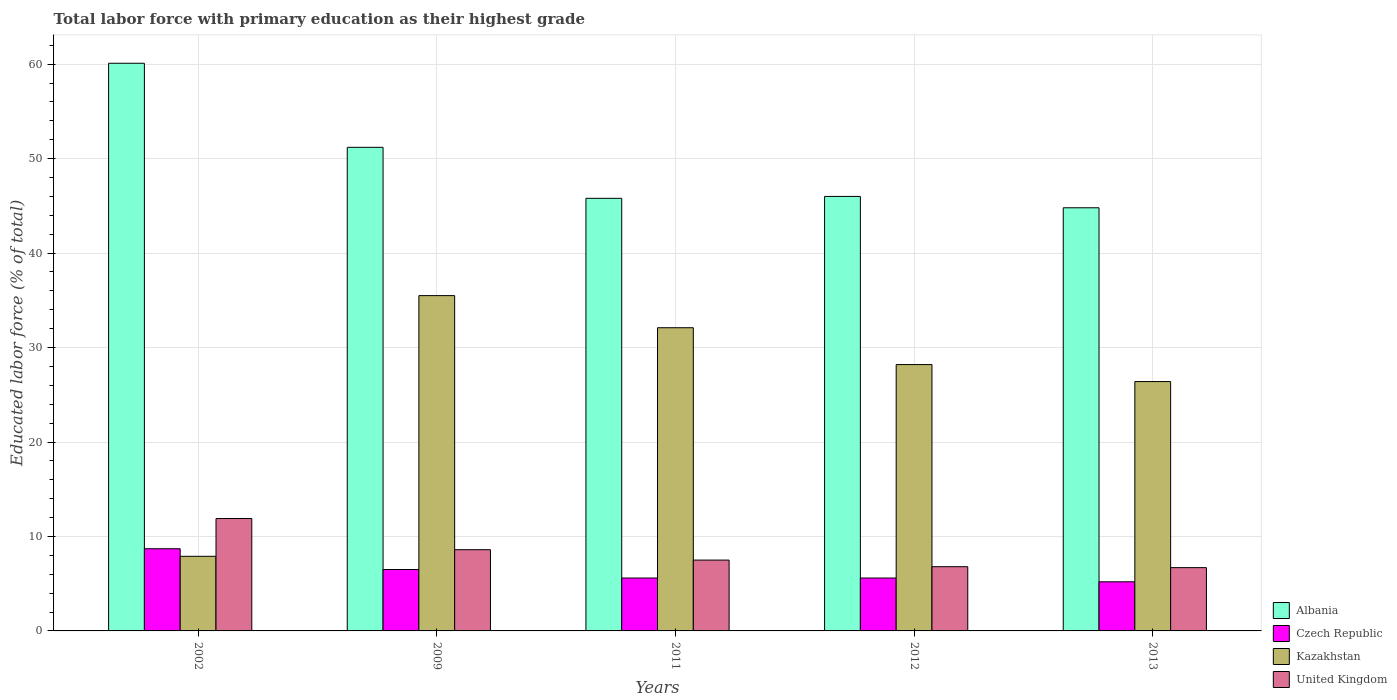How many groups of bars are there?
Keep it short and to the point. 5. Are the number of bars per tick equal to the number of legend labels?
Your answer should be very brief. Yes. Are the number of bars on each tick of the X-axis equal?
Give a very brief answer. Yes. How many bars are there on the 1st tick from the right?
Provide a short and direct response. 4. What is the label of the 1st group of bars from the left?
Your answer should be very brief. 2002. What is the percentage of total labor force with primary education in Czech Republic in 2013?
Provide a succinct answer. 5.2. Across all years, what is the maximum percentage of total labor force with primary education in United Kingdom?
Give a very brief answer. 11.9. Across all years, what is the minimum percentage of total labor force with primary education in Kazakhstan?
Your response must be concise. 7.9. In which year was the percentage of total labor force with primary education in Albania maximum?
Give a very brief answer. 2002. What is the total percentage of total labor force with primary education in Kazakhstan in the graph?
Provide a short and direct response. 130.1. What is the difference between the percentage of total labor force with primary education in Kazakhstan in 2009 and that in 2013?
Provide a short and direct response. 9.1. What is the difference between the percentage of total labor force with primary education in Czech Republic in 2002 and the percentage of total labor force with primary education in United Kingdom in 2013?
Your answer should be very brief. 2. What is the average percentage of total labor force with primary education in Kazakhstan per year?
Offer a terse response. 26.02. In the year 2009, what is the difference between the percentage of total labor force with primary education in United Kingdom and percentage of total labor force with primary education in Albania?
Your response must be concise. -42.6. In how many years, is the percentage of total labor force with primary education in Czech Republic greater than 20 %?
Ensure brevity in your answer.  0. What is the ratio of the percentage of total labor force with primary education in Albania in 2002 to that in 2013?
Give a very brief answer. 1.34. Is the percentage of total labor force with primary education in Kazakhstan in 2009 less than that in 2012?
Keep it short and to the point. No. What is the difference between the highest and the second highest percentage of total labor force with primary education in Czech Republic?
Your answer should be compact. 2.2. What is the difference between the highest and the lowest percentage of total labor force with primary education in Czech Republic?
Offer a terse response. 3.5. In how many years, is the percentage of total labor force with primary education in Czech Republic greater than the average percentage of total labor force with primary education in Czech Republic taken over all years?
Give a very brief answer. 2. Is it the case that in every year, the sum of the percentage of total labor force with primary education in Kazakhstan and percentage of total labor force with primary education in Czech Republic is greater than the sum of percentage of total labor force with primary education in United Kingdom and percentage of total labor force with primary education in Albania?
Give a very brief answer. No. What does the 4th bar from the left in 2013 represents?
Ensure brevity in your answer.  United Kingdom. What does the 4th bar from the right in 2002 represents?
Provide a succinct answer. Albania. How many years are there in the graph?
Ensure brevity in your answer.  5. Does the graph contain grids?
Ensure brevity in your answer.  Yes. How many legend labels are there?
Offer a terse response. 4. How are the legend labels stacked?
Your answer should be very brief. Vertical. What is the title of the graph?
Offer a very short reply. Total labor force with primary education as their highest grade. Does "Lao PDR" appear as one of the legend labels in the graph?
Give a very brief answer. No. What is the label or title of the X-axis?
Ensure brevity in your answer.  Years. What is the label or title of the Y-axis?
Make the answer very short. Educated labor force (% of total). What is the Educated labor force (% of total) in Albania in 2002?
Offer a very short reply. 60.1. What is the Educated labor force (% of total) of Czech Republic in 2002?
Provide a short and direct response. 8.7. What is the Educated labor force (% of total) of Kazakhstan in 2002?
Offer a terse response. 7.9. What is the Educated labor force (% of total) of United Kingdom in 2002?
Offer a terse response. 11.9. What is the Educated labor force (% of total) of Albania in 2009?
Provide a short and direct response. 51.2. What is the Educated labor force (% of total) in Czech Republic in 2009?
Give a very brief answer. 6.5. What is the Educated labor force (% of total) of Kazakhstan in 2009?
Give a very brief answer. 35.5. What is the Educated labor force (% of total) in United Kingdom in 2009?
Offer a very short reply. 8.6. What is the Educated labor force (% of total) of Albania in 2011?
Offer a terse response. 45.8. What is the Educated labor force (% of total) of Czech Republic in 2011?
Offer a very short reply. 5.6. What is the Educated labor force (% of total) in Kazakhstan in 2011?
Make the answer very short. 32.1. What is the Educated labor force (% of total) of Albania in 2012?
Offer a very short reply. 46. What is the Educated labor force (% of total) of Czech Republic in 2012?
Give a very brief answer. 5.6. What is the Educated labor force (% of total) in Kazakhstan in 2012?
Your response must be concise. 28.2. What is the Educated labor force (% of total) in United Kingdom in 2012?
Ensure brevity in your answer.  6.8. What is the Educated labor force (% of total) in Albania in 2013?
Provide a succinct answer. 44.8. What is the Educated labor force (% of total) in Czech Republic in 2013?
Your answer should be compact. 5.2. What is the Educated labor force (% of total) of Kazakhstan in 2013?
Ensure brevity in your answer.  26.4. What is the Educated labor force (% of total) of United Kingdom in 2013?
Your response must be concise. 6.7. Across all years, what is the maximum Educated labor force (% of total) of Albania?
Your answer should be very brief. 60.1. Across all years, what is the maximum Educated labor force (% of total) in Czech Republic?
Provide a succinct answer. 8.7. Across all years, what is the maximum Educated labor force (% of total) in Kazakhstan?
Your response must be concise. 35.5. Across all years, what is the maximum Educated labor force (% of total) in United Kingdom?
Make the answer very short. 11.9. Across all years, what is the minimum Educated labor force (% of total) of Albania?
Your answer should be compact. 44.8. Across all years, what is the minimum Educated labor force (% of total) of Czech Republic?
Your answer should be compact. 5.2. Across all years, what is the minimum Educated labor force (% of total) of Kazakhstan?
Keep it short and to the point. 7.9. Across all years, what is the minimum Educated labor force (% of total) in United Kingdom?
Your answer should be compact. 6.7. What is the total Educated labor force (% of total) in Albania in the graph?
Provide a short and direct response. 247.9. What is the total Educated labor force (% of total) of Czech Republic in the graph?
Offer a very short reply. 31.6. What is the total Educated labor force (% of total) of Kazakhstan in the graph?
Ensure brevity in your answer.  130.1. What is the total Educated labor force (% of total) of United Kingdom in the graph?
Provide a succinct answer. 41.5. What is the difference between the Educated labor force (% of total) in Kazakhstan in 2002 and that in 2009?
Give a very brief answer. -27.6. What is the difference between the Educated labor force (% of total) in United Kingdom in 2002 and that in 2009?
Provide a short and direct response. 3.3. What is the difference between the Educated labor force (% of total) of Albania in 2002 and that in 2011?
Ensure brevity in your answer.  14.3. What is the difference between the Educated labor force (% of total) in Czech Republic in 2002 and that in 2011?
Make the answer very short. 3.1. What is the difference between the Educated labor force (% of total) of Kazakhstan in 2002 and that in 2011?
Ensure brevity in your answer.  -24.2. What is the difference between the Educated labor force (% of total) in Kazakhstan in 2002 and that in 2012?
Offer a very short reply. -20.3. What is the difference between the Educated labor force (% of total) in Albania in 2002 and that in 2013?
Offer a terse response. 15.3. What is the difference between the Educated labor force (% of total) of Kazakhstan in 2002 and that in 2013?
Give a very brief answer. -18.5. What is the difference between the Educated labor force (% of total) of Albania in 2009 and that in 2011?
Your answer should be compact. 5.4. What is the difference between the Educated labor force (% of total) of Czech Republic in 2009 and that in 2011?
Your answer should be very brief. 0.9. What is the difference between the Educated labor force (% of total) in United Kingdom in 2009 and that in 2013?
Give a very brief answer. 1.9. What is the difference between the Educated labor force (% of total) in Albania in 2011 and that in 2012?
Keep it short and to the point. -0.2. What is the difference between the Educated labor force (% of total) in Kazakhstan in 2011 and that in 2012?
Your answer should be very brief. 3.9. What is the difference between the Educated labor force (% of total) of United Kingdom in 2011 and that in 2012?
Ensure brevity in your answer.  0.7. What is the difference between the Educated labor force (% of total) in Albania in 2011 and that in 2013?
Your response must be concise. 1. What is the difference between the Educated labor force (% of total) of Czech Republic in 2011 and that in 2013?
Your response must be concise. 0.4. What is the difference between the Educated labor force (% of total) of Kazakhstan in 2011 and that in 2013?
Your answer should be very brief. 5.7. What is the difference between the Educated labor force (% of total) of Albania in 2012 and that in 2013?
Provide a succinct answer. 1.2. What is the difference between the Educated labor force (% of total) in United Kingdom in 2012 and that in 2013?
Offer a very short reply. 0.1. What is the difference between the Educated labor force (% of total) of Albania in 2002 and the Educated labor force (% of total) of Czech Republic in 2009?
Offer a terse response. 53.6. What is the difference between the Educated labor force (% of total) of Albania in 2002 and the Educated labor force (% of total) of Kazakhstan in 2009?
Keep it short and to the point. 24.6. What is the difference between the Educated labor force (% of total) in Albania in 2002 and the Educated labor force (% of total) in United Kingdom in 2009?
Provide a short and direct response. 51.5. What is the difference between the Educated labor force (% of total) of Czech Republic in 2002 and the Educated labor force (% of total) of Kazakhstan in 2009?
Your answer should be very brief. -26.8. What is the difference between the Educated labor force (% of total) in Czech Republic in 2002 and the Educated labor force (% of total) in United Kingdom in 2009?
Keep it short and to the point. 0.1. What is the difference between the Educated labor force (% of total) in Albania in 2002 and the Educated labor force (% of total) in Czech Republic in 2011?
Keep it short and to the point. 54.5. What is the difference between the Educated labor force (% of total) of Albania in 2002 and the Educated labor force (% of total) of United Kingdom in 2011?
Your response must be concise. 52.6. What is the difference between the Educated labor force (% of total) in Czech Republic in 2002 and the Educated labor force (% of total) in Kazakhstan in 2011?
Make the answer very short. -23.4. What is the difference between the Educated labor force (% of total) in Czech Republic in 2002 and the Educated labor force (% of total) in United Kingdom in 2011?
Provide a short and direct response. 1.2. What is the difference between the Educated labor force (% of total) in Albania in 2002 and the Educated labor force (% of total) in Czech Republic in 2012?
Offer a very short reply. 54.5. What is the difference between the Educated labor force (% of total) of Albania in 2002 and the Educated labor force (% of total) of Kazakhstan in 2012?
Your response must be concise. 31.9. What is the difference between the Educated labor force (% of total) in Albania in 2002 and the Educated labor force (% of total) in United Kingdom in 2012?
Offer a very short reply. 53.3. What is the difference between the Educated labor force (% of total) of Czech Republic in 2002 and the Educated labor force (% of total) of Kazakhstan in 2012?
Make the answer very short. -19.5. What is the difference between the Educated labor force (% of total) in Czech Republic in 2002 and the Educated labor force (% of total) in United Kingdom in 2012?
Make the answer very short. 1.9. What is the difference between the Educated labor force (% of total) of Albania in 2002 and the Educated labor force (% of total) of Czech Republic in 2013?
Ensure brevity in your answer.  54.9. What is the difference between the Educated labor force (% of total) of Albania in 2002 and the Educated labor force (% of total) of Kazakhstan in 2013?
Provide a short and direct response. 33.7. What is the difference between the Educated labor force (% of total) of Albania in 2002 and the Educated labor force (% of total) of United Kingdom in 2013?
Make the answer very short. 53.4. What is the difference between the Educated labor force (% of total) of Czech Republic in 2002 and the Educated labor force (% of total) of Kazakhstan in 2013?
Provide a succinct answer. -17.7. What is the difference between the Educated labor force (% of total) of Czech Republic in 2002 and the Educated labor force (% of total) of United Kingdom in 2013?
Keep it short and to the point. 2. What is the difference between the Educated labor force (% of total) in Kazakhstan in 2002 and the Educated labor force (% of total) in United Kingdom in 2013?
Give a very brief answer. 1.2. What is the difference between the Educated labor force (% of total) in Albania in 2009 and the Educated labor force (% of total) in Czech Republic in 2011?
Ensure brevity in your answer.  45.6. What is the difference between the Educated labor force (% of total) in Albania in 2009 and the Educated labor force (% of total) in United Kingdom in 2011?
Ensure brevity in your answer.  43.7. What is the difference between the Educated labor force (% of total) in Czech Republic in 2009 and the Educated labor force (% of total) in Kazakhstan in 2011?
Provide a short and direct response. -25.6. What is the difference between the Educated labor force (% of total) in Czech Republic in 2009 and the Educated labor force (% of total) in United Kingdom in 2011?
Make the answer very short. -1. What is the difference between the Educated labor force (% of total) of Albania in 2009 and the Educated labor force (% of total) of Czech Republic in 2012?
Offer a terse response. 45.6. What is the difference between the Educated labor force (% of total) in Albania in 2009 and the Educated labor force (% of total) in United Kingdom in 2012?
Give a very brief answer. 44.4. What is the difference between the Educated labor force (% of total) in Czech Republic in 2009 and the Educated labor force (% of total) in Kazakhstan in 2012?
Your answer should be compact. -21.7. What is the difference between the Educated labor force (% of total) in Kazakhstan in 2009 and the Educated labor force (% of total) in United Kingdom in 2012?
Your response must be concise. 28.7. What is the difference between the Educated labor force (% of total) in Albania in 2009 and the Educated labor force (% of total) in Kazakhstan in 2013?
Give a very brief answer. 24.8. What is the difference between the Educated labor force (% of total) in Albania in 2009 and the Educated labor force (% of total) in United Kingdom in 2013?
Keep it short and to the point. 44.5. What is the difference between the Educated labor force (% of total) of Czech Republic in 2009 and the Educated labor force (% of total) of Kazakhstan in 2013?
Your answer should be compact. -19.9. What is the difference between the Educated labor force (% of total) of Czech Republic in 2009 and the Educated labor force (% of total) of United Kingdom in 2013?
Give a very brief answer. -0.2. What is the difference between the Educated labor force (% of total) of Kazakhstan in 2009 and the Educated labor force (% of total) of United Kingdom in 2013?
Provide a succinct answer. 28.8. What is the difference between the Educated labor force (% of total) in Albania in 2011 and the Educated labor force (% of total) in Czech Republic in 2012?
Your answer should be very brief. 40.2. What is the difference between the Educated labor force (% of total) in Albania in 2011 and the Educated labor force (% of total) in Kazakhstan in 2012?
Your response must be concise. 17.6. What is the difference between the Educated labor force (% of total) in Albania in 2011 and the Educated labor force (% of total) in United Kingdom in 2012?
Your answer should be compact. 39. What is the difference between the Educated labor force (% of total) in Czech Republic in 2011 and the Educated labor force (% of total) in Kazakhstan in 2012?
Provide a short and direct response. -22.6. What is the difference between the Educated labor force (% of total) of Czech Republic in 2011 and the Educated labor force (% of total) of United Kingdom in 2012?
Your response must be concise. -1.2. What is the difference between the Educated labor force (% of total) of Kazakhstan in 2011 and the Educated labor force (% of total) of United Kingdom in 2012?
Offer a terse response. 25.3. What is the difference between the Educated labor force (% of total) of Albania in 2011 and the Educated labor force (% of total) of Czech Republic in 2013?
Provide a short and direct response. 40.6. What is the difference between the Educated labor force (% of total) of Albania in 2011 and the Educated labor force (% of total) of Kazakhstan in 2013?
Make the answer very short. 19.4. What is the difference between the Educated labor force (% of total) in Albania in 2011 and the Educated labor force (% of total) in United Kingdom in 2013?
Your answer should be compact. 39.1. What is the difference between the Educated labor force (% of total) in Czech Republic in 2011 and the Educated labor force (% of total) in Kazakhstan in 2013?
Your response must be concise. -20.8. What is the difference between the Educated labor force (% of total) in Kazakhstan in 2011 and the Educated labor force (% of total) in United Kingdom in 2013?
Your answer should be compact. 25.4. What is the difference between the Educated labor force (% of total) in Albania in 2012 and the Educated labor force (% of total) in Czech Republic in 2013?
Give a very brief answer. 40.8. What is the difference between the Educated labor force (% of total) of Albania in 2012 and the Educated labor force (% of total) of Kazakhstan in 2013?
Offer a very short reply. 19.6. What is the difference between the Educated labor force (% of total) in Albania in 2012 and the Educated labor force (% of total) in United Kingdom in 2013?
Provide a short and direct response. 39.3. What is the difference between the Educated labor force (% of total) of Czech Republic in 2012 and the Educated labor force (% of total) of Kazakhstan in 2013?
Ensure brevity in your answer.  -20.8. What is the difference between the Educated labor force (% of total) in Kazakhstan in 2012 and the Educated labor force (% of total) in United Kingdom in 2013?
Offer a terse response. 21.5. What is the average Educated labor force (% of total) of Albania per year?
Make the answer very short. 49.58. What is the average Educated labor force (% of total) of Czech Republic per year?
Your response must be concise. 6.32. What is the average Educated labor force (% of total) in Kazakhstan per year?
Make the answer very short. 26.02. What is the average Educated labor force (% of total) of United Kingdom per year?
Your answer should be very brief. 8.3. In the year 2002, what is the difference between the Educated labor force (% of total) in Albania and Educated labor force (% of total) in Czech Republic?
Ensure brevity in your answer.  51.4. In the year 2002, what is the difference between the Educated labor force (% of total) in Albania and Educated labor force (% of total) in Kazakhstan?
Provide a succinct answer. 52.2. In the year 2002, what is the difference between the Educated labor force (% of total) in Albania and Educated labor force (% of total) in United Kingdom?
Offer a very short reply. 48.2. In the year 2002, what is the difference between the Educated labor force (% of total) of Czech Republic and Educated labor force (% of total) of United Kingdom?
Offer a very short reply. -3.2. In the year 2009, what is the difference between the Educated labor force (% of total) in Albania and Educated labor force (% of total) in Czech Republic?
Your answer should be compact. 44.7. In the year 2009, what is the difference between the Educated labor force (% of total) of Albania and Educated labor force (% of total) of Kazakhstan?
Make the answer very short. 15.7. In the year 2009, what is the difference between the Educated labor force (% of total) of Albania and Educated labor force (% of total) of United Kingdom?
Give a very brief answer. 42.6. In the year 2009, what is the difference between the Educated labor force (% of total) of Czech Republic and Educated labor force (% of total) of Kazakhstan?
Your answer should be very brief. -29. In the year 2009, what is the difference between the Educated labor force (% of total) of Czech Republic and Educated labor force (% of total) of United Kingdom?
Provide a short and direct response. -2.1. In the year 2009, what is the difference between the Educated labor force (% of total) of Kazakhstan and Educated labor force (% of total) of United Kingdom?
Make the answer very short. 26.9. In the year 2011, what is the difference between the Educated labor force (% of total) in Albania and Educated labor force (% of total) in Czech Republic?
Provide a succinct answer. 40.2. In the year 2011, what is the difference between the Educated labor force (% of total) in Albania and Educated labor force (% of total) in Kazakhstan?
Offer a terse response. 13.7. In the year 2011, what is the difference between the Educated labor force (% of total) of Albania and Educated labor force (% of total) of United Kingdom?
Ensure brevity in your answer.  38.3. In the year 2011, what is the difference between the Educated labor force (% of total) of Czech Republic and Educated labor force (% of total) of Kazakhstan?
Provide a succinct answer. -26.5. In the year 2011, what is the difference between the Educated labor force (% of total) of Kazakhstan and Educated labor force (% of total) of United Kingdom?
Ensure brevity in your answer.  24.6. In the year 2012, what is the difference between the Educated labor force (% of total) in Albania and Educated labor force (% of total) in Czech Republic?
Make the answer very short. 40.4. In the year 2012, what is the difference between the Educated labor force (% of total) in Albania and Educated labor force (% of total) in Kazakhstan?
Give a very brief answer. 17.8. In the year 2012, what is the difference between the Educated labor force (% of total) in Albania and Educated labor force (% of total) in United Kingdom?
Make the answer very short. 39.2. In the year 2012, what is the difference between the Educated labor force (% of total) of Czech Republic and Educated labor force (% of total) of Kazakhstan?
Your answer should be compact. -22.6. In the year 2012, what is the difference between the Educated labor force (% of total) in Kazakhstan and Educated labor force (% of total) in United Kingdom?
Offer a terse response. 21.4. In the year 2013, what is the difference between the Educated labor force (% of total) of Albania and Educated labor force (% of total) of Czech Republic?
Your answer should be very brief. 39.6. In the year 2013, what is the difference between the Educated labor force (% of total) of Albania and Educated labor force (% of total) of United Kingdom?
Offer a very short reply. 38.1. In the year 2013, what is the difference between the Educated labor force (% of total) of Czech Republic and Educated labor force (% of total) of Kazakhstan?
Your answer should be compact. -21.2. In the year 2013, what is the difference between the Educated labor force (% of total) in Czech Republic and Educated labor force (% of total) in United Kingdom?
Your response must be concise. -1.5. In the year 2013, what is the difference between the Educated labor force (% of total) of Kazakhstan and Educated labor force (% of total) of United Kingdom?
Your answer should be very brief. 19.7. What is the ratio of the Educated labor force (% of total) in Albania in 2002 to that in 2009?
Offer a very short reply. 1.17. What is the ratio of the Educated labor force (% of total) of Czech Republic in 2002 to that in 2009?
Offer a very short reply. 1.34. What is the ratio of the Educated labor force (% of total) of Kazakhstan in 2002 to that in 2009?
Offer a very short reply. 0.22. What is the ratio of the Educated labor force (% of total) of United Kingdom in 2002 to that in 2009?
Ensure brevity in your answer.  1.38. What is the ratio of the Educated labor force (% of total) in Albania in 2002 to that in 2011?
Your answer should be very brief. 1.31. What is the ratio of the Educated labor force (% of total) of Czech Republic in 2002 to that in 2011?
Offer a very short reply. 1.55. What is the ratio of the Educated labor force (% of total) in Kazakhstan in 2002 to that in 2011?
Keep it short and to the point. 0.25. What is the ratio of the Educated labor force (% of total) in United Kingdom in 2002 to that in 2011?
Offer a very short reply. 1.59. What is the ratio of the Educated labor force (% of total) in Albania in 2002 to that in 2012?
Give a very brief answer. 1.31. What is the ratio of the Educated labor force (% of total) of Czech Republic in 2002 to that in 2012?
Your answer should be very brief. 1.55. What is the ratio of the Educated labor force (% of total) in Kazakhstan in 2002 to that in 2012?
Provide a succinct answer. 0.28. What is the ratio of the Educated labor force (% of total) of United Kingdom in 2002 to that in 2012?
Keep it short and to the point. 1.75. What is the ratio of the Educated labor force (% of total) of Albania in 2002 to that in 2013?
Make the answer very short. 1.34. What is the ratio of the Educated labor force (% of total) of Czech Republic in 2002 to that in 2013?
Provide a short and direct response. 1.67. What is the ratio of the Educated labor force (% of total) of Kazakhstan in 2002 to that in 2013?
Give a very brief answer. 0.3. What is the ratio of the Educated labor force (% of total) in United Kingdom in 2002 to that in 2013?
Ensure brevity in your answer.  1.78. What is the ratio of the Educated labor force (% of total) of Albania in 2009 to that in 2011?
Make the answer very short. 1.12. What is the ratio of the Educated labor force (% of total) of Czech Republic in 2009 to that in 2011?
Ensure brevity in your answer.  1.16. What is the ratio of the Educated labor force (% of total) of Kazakhstan in 2009 to that in 2011?
Provide a short and direct response. 1.11. What is the ratio of the Educated labor force (% of total) of United Kingdom in 2009 to that in 2011?
Provide a succinct answer. 1.15. What is the ratio of the Educated labor force (% of total) of Albania in 2009 to that in 2012?
Provide a short and direct response. 1.11. What is the ratio of the Educated labor force (% of total) of Czech Republic in 2009 to that in 2012?
Your answer should be compact. 1.16. What is the ratio of the Educated labor force (% of total) in Kazakhstan in 2009 to that in 2012?
Your response must be concise. 1.26. What is the ratio of the Educated labor force (% of total) of United Kingdom in 2009 to that in 2012?
Your answer should be compact. 1.26. What is the ratio of the Educated labor force (% of total) of Czech Republic in 2009 to that in 2013?
Keep it short and to the point. 1.25. What is the ratio of the Educated labor force (% of total) in Kazakhstan in 2009 to that in 2013?
Ensure brevity in your answer.  1.34. What is the ratio of the Educated labor force (% of total) of United Kingdom in 2009 to that in 2013?
Your response must be concise. 1.28. What is the ratio of the Educated labor force (% of total) in Kazakhstan in 2011 to that in 2012?
Keep it short and to the point. 1.14. What is the ratio of the Educated labor force (% of total) of United Kingdom in 2011 to that in 2012?
Your response must be concise. 1.1. What is the ratio of the Educated labor force (% of total) of Albania in 2011 to that in 2013?
Make the answer very short. 1.02. What is the ratio of the Educated labor force (% of total) in Czech Republic in 2011 to that in 2013?
Provide a succinct answer. 1.08. What is the ratio of the Educated labor force (% of total) in Kazakhstan in 2011 to that in 2013?
Keep it short and to the point. 1.22. What is the ratio of the Educated labor force (% of total) of United Kingdom in 2011 to that in 2013?
Offer a terse response. 1.12. What is the ratio of the Educated labor force (% of total) in Albania in 2012 to that in 2013?
Provide a short and direct response. 1.03. What is the ratio of the Educated labor force (% of total) in Kazakhstan in 2012 to that in 2013?
Give a very brief answer. 1.07. What is the ratio of the Educated labor force (% of total) in United Kingdom in 2012 to that in 2013?
Your answer should be compact. 1.01. What is the difference between the highest and the second highest Educated labor force (% of total) in Albania?
Your answer should be compact. 8.9. What is the difference between the highest and the second highest Educated labor force (% of total) in Czech Republic?
Offer a very short reply. 2.2. What is the difference between the highest and the second highest Educated labor force (% of total) in Kazakhstan?
Give a very brief answer. 3.4. What is the difference between the highest and the lowest Educated labor force (% of total) of Kazakhstan?
Your answer should be very brief. 27.6. 